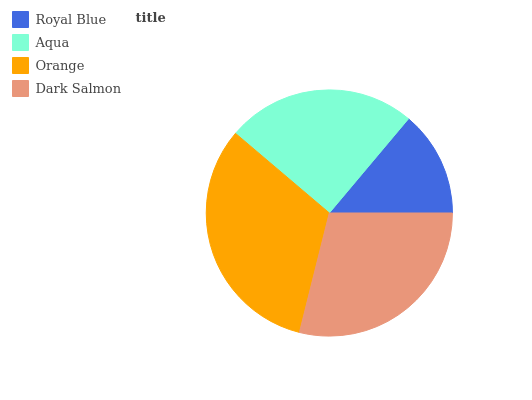Is Royal Blue the minimum?
Answer yes or no. Yes. Is Orange the maximum?
Answer yes or no. Yes. Is Aqua the minimum?
Answer yes or no. No. Is Aqua the maximum?
Answer yes or no. No. Is Aqua greater than Royal Blue?
Answer yes or no. Yes. Is Royal Blue less than Aqua?
Answer yes or no. Yes. Is Royal Blue greater than Aqua?
Answer yes or no. No. Is Aqua less than Royal Blue?
Answer yes or no. No. Is Dark Salmon the high median?
Answer yes or no. Yes. Is Aqua the low median?
Answer yes or no. Yes. Is Royal Blue the high median?
Answer yes or no. No. Is Orange the low median?
Answer yes or no. No. 